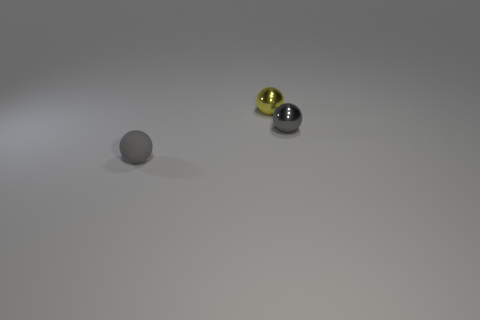Subtract all tiny gray spheres. How many spheres are left? 1 Add 3 small purple matte cylinders. How many objects exist? 6 Subtract all purple cubes. How many gray balls are left? 2 Subtract all yellow spheres. How many spheres are left? 2 Subtract 3 balls. How many balls are left? 0 Add 1 gray matte objects. How many gray matte objects are left? 2 Add 3 gray spheres. How many gray spheres exist? 5 Subtract 0 red spheres. How many objects are left? 3 Subtract all brown balls. Subtract all cyan cylinders. How many balls are left? 3 Subtract all small gray balls. Subtract all yellow metallic balls. How many objects are left? 0 